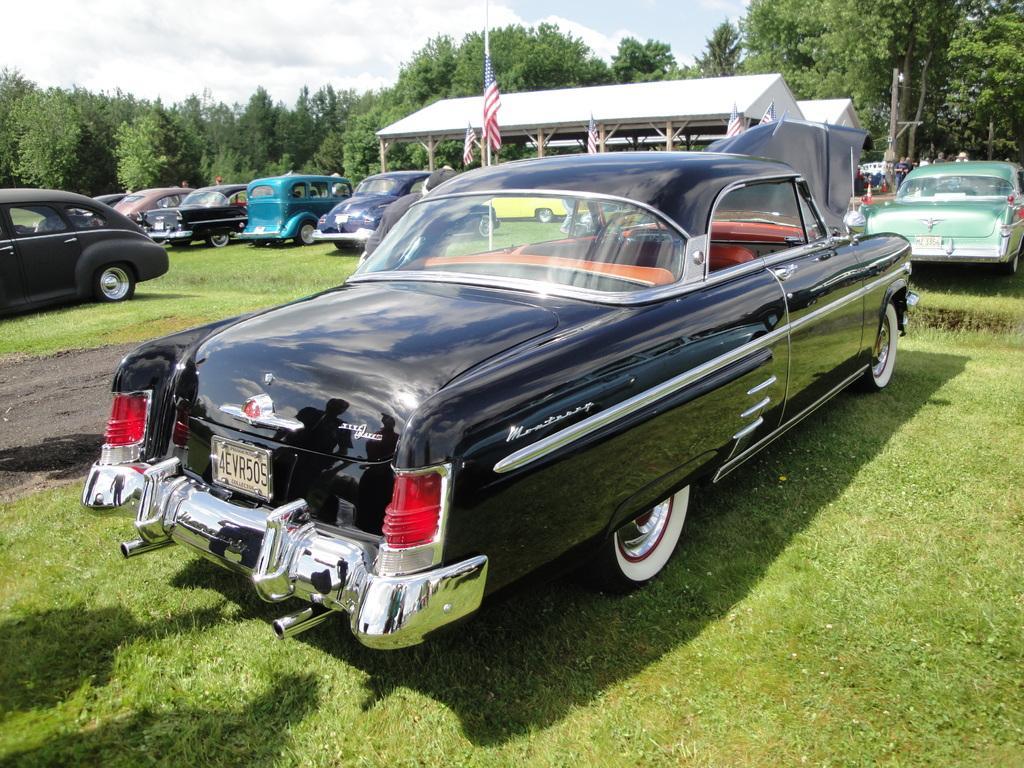Could you give a brief overview of what you see in this image? In this image I can see many vehicles on the grass. In the background I can see the flags, shed, many trees, clouds and the sky. 